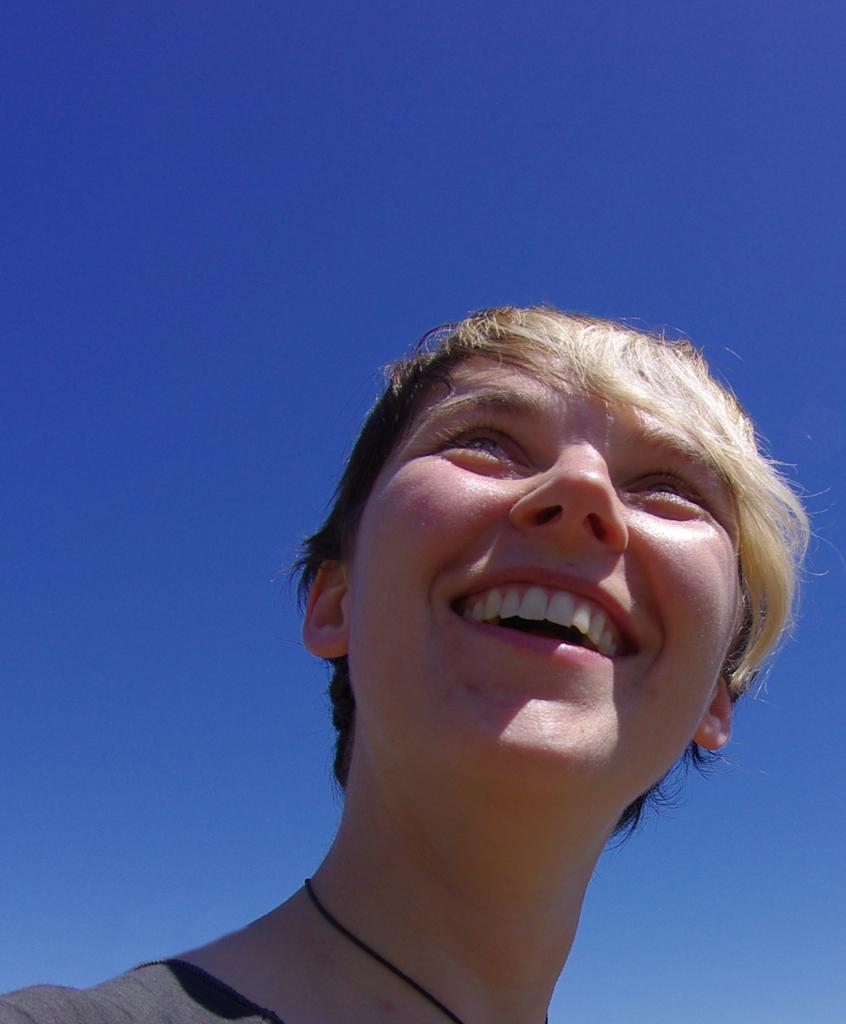Describe this image in one or two sentences. In this image in the foreground there is one woman who is smiling, and in the background there is sky. 